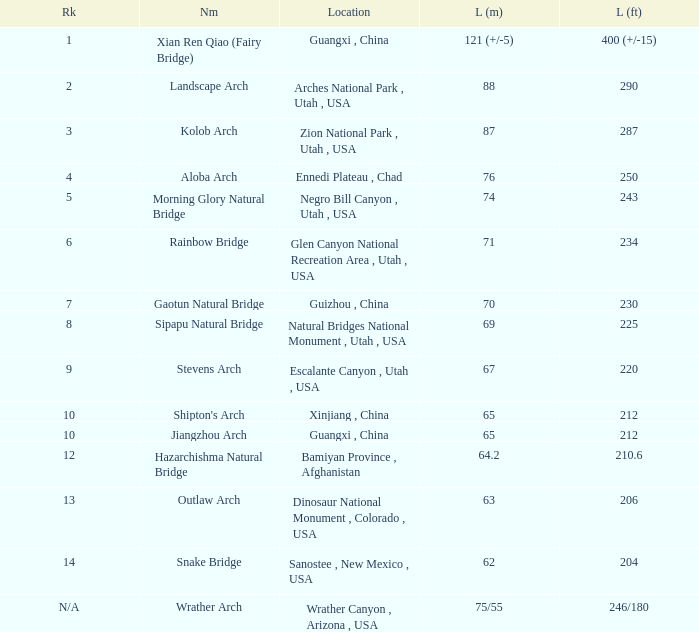Where does the longest arch, having a length of 63 meters, exist? Dinosaur National Monument , Colorado , USA. 